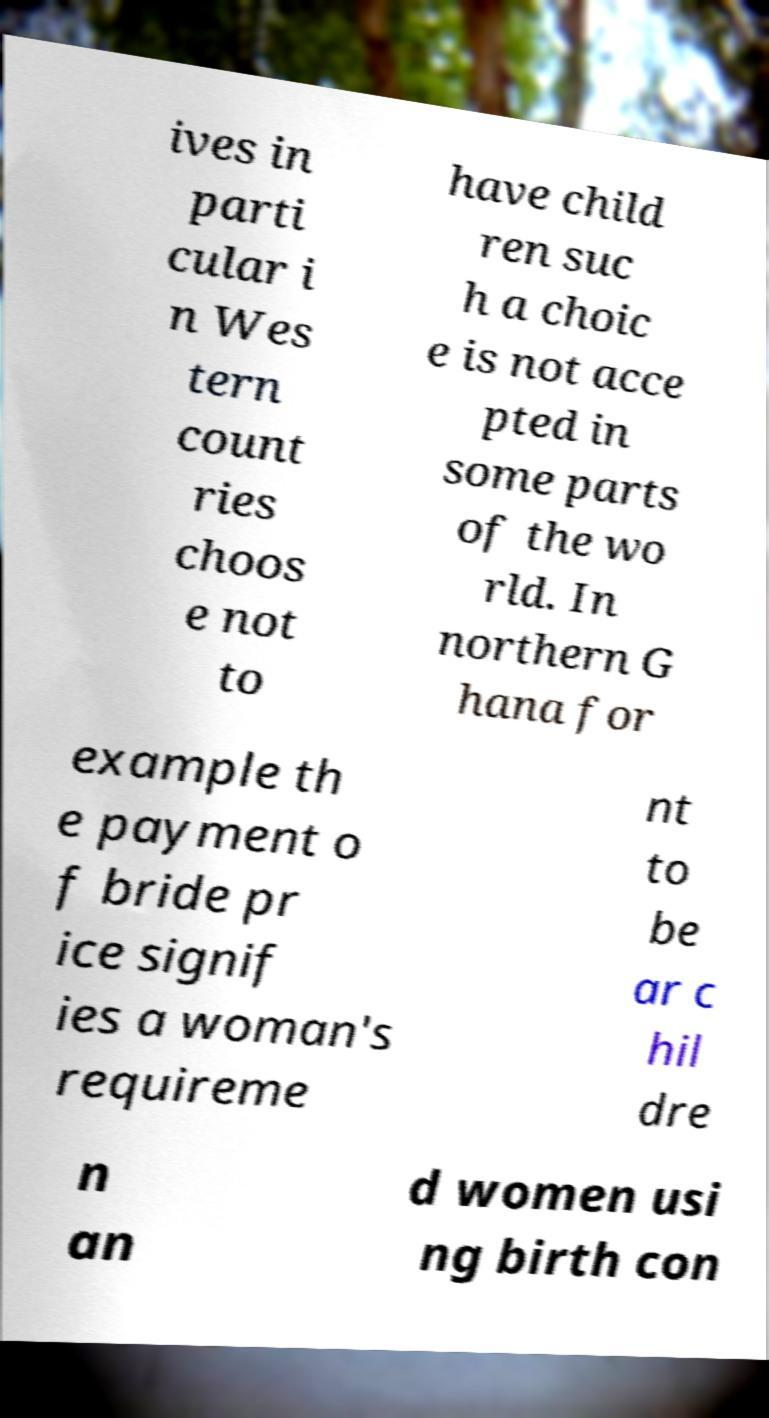Please read and relay the text visible in this image. What does it say? ives in parti cular i n Wes tern count ries choos e not to have child ren suc h a choic e is not acce pted in some parts of the wo rld. In northern G hana for example th e payment o f bride pr ice signif ies a woman's requireme nt to be ar c hil dre n an d women usi ng birth con 